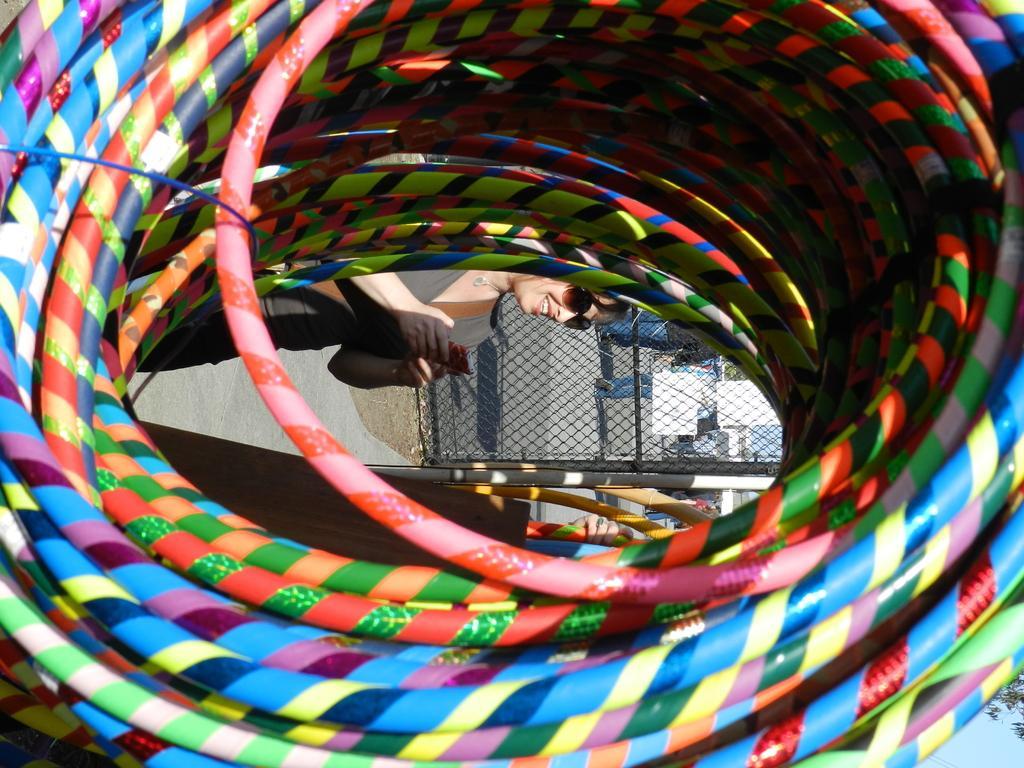How would you summarize this image in a sentence or two? In this image I can see a bundle of pipe which is colorful and through the gap I can see a woman standing, the ground, the metal fencing and few buildings. 